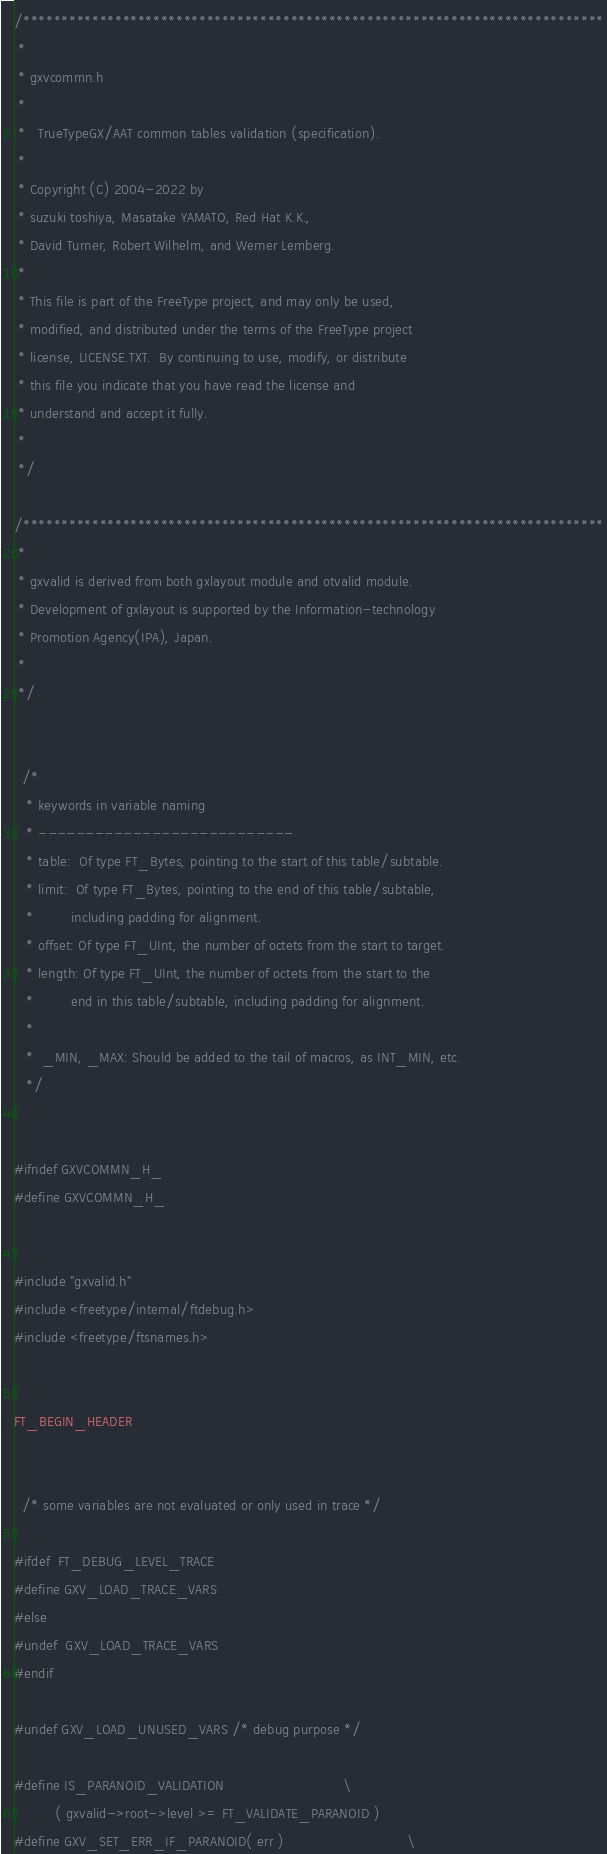<code> <loc_0><loc_0><loc_500><loc_500><_C_>/****************************************************************************
 *
 * gxvcommn.h
 *
 *   TrueTypeGX/AAT common tables validation (specification).
 *
 * Copyright (C) 2004-2022 by
 * suzuki toshiya, Masatake YAMATO, Red Hat K.K.,
 * David Turner, Robert Wilhelm, and Werner Lemberg.
 *
 * This file is part of the FreeType project, and may only be used,
 * modified, and distributed under the terms of the FreeType project
 * license, LICENSE.TXT.  By continuing to use, modify, or distribute
 * this file you indicate that you have read the license and
 * understand and accept it fully.
 *
 */

/****************************************************************************
 *
 * gxvalid is derived from both gxlayout module and otvalid module.
 * Development of gxlayout is supported by the Information-technology
 * Promotion Agency(IPA), Japan.
 *
 */


  /*
   * keywords in variable naming
   * ---------------------------
   * table:  Of type FT_Bytes, pointing to the start of this table/subtable.
   * limit:  Of type FT_Bytes, pointing to the end of this table/subtable,
   *         including padding for alignment.
   * offset: Of type FT_UInt, the number of octets from the start to target.
   * length: Of type FT_UInt, the number of octets from the start to the
   *         end in this table/subtable, including padding for alignment.
   *
   *  _MIN, _MAX: Should be added to the tail of macros, as INT_MIN, etc.
   */


#ifndef GXVCOMMN_H_
#define GXVCOMMN_H_


#include "gxvalid.h"
#include <freetype/internal/ftdebug.h>
#include <freetype/ftsnames.h>


FT_BEGIN_HEADER


  /* some variables are not evaluated or only used in trace */

#ifdef  FT_DEBUG_LEVEL_TRACE
#define GXV_LOAD_TRACE_VARS
#else
#undef  GXV_LOAD_TRACE_VARS
#endif

#undef GXV_LOAD_UNUSED_VARS /* debug purpose */

#define IS_PARANOID_VALIDATION                             \
          ( gxvalid->root->level >= FT_VALIDATE_PARANOID )
#define GXV_SET_ERR_IF_PARANOID( err )                              \</code> 